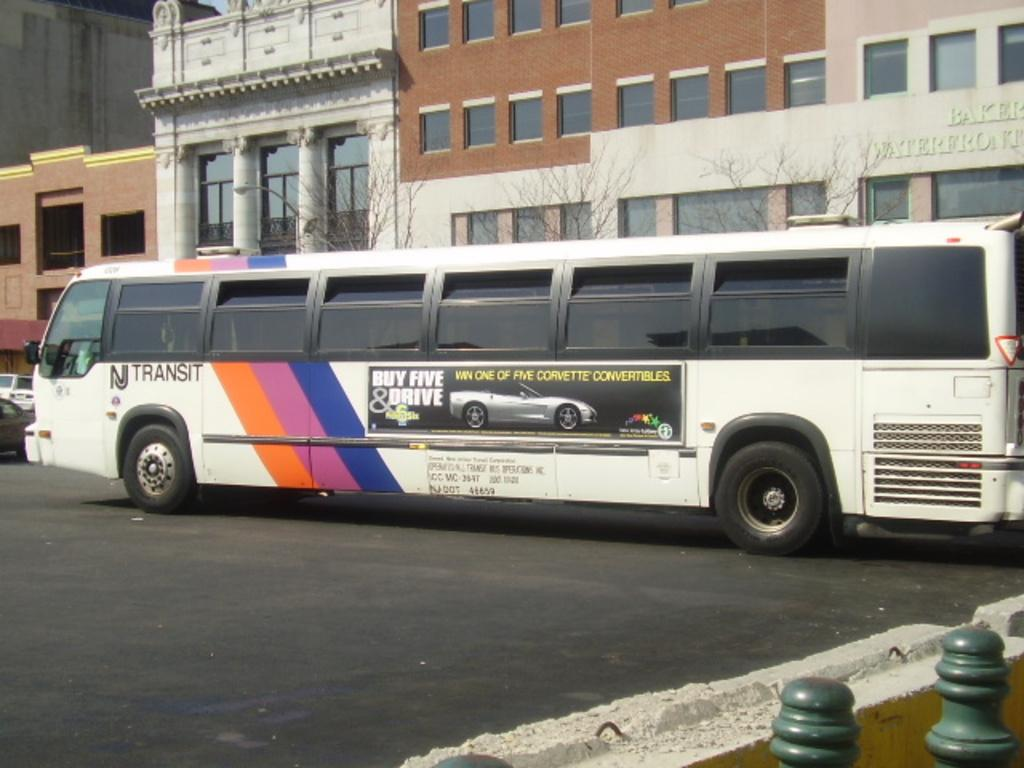What structures can be seen in the image? There are poles and buildings visible in the image. What type of transportation can be seen on the road in the image? There are vehicles on the road in the image. What can be seen in the background of the image? There are buildings, light, and trees visible in the background of the image. How many clovers are growing in the yard in the image? There is no yard or clover present in the image. 